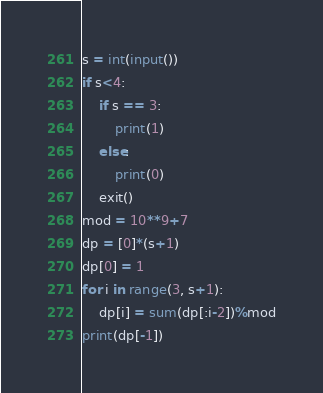Convert code to text. <code><loc_0><loc_0><loc_500><loc_500><_Python_>s = int(input())
if s<4:
    if s == 3:
        print(1)
    else:
        print(0)
    exit()
mod = 10**9+7
dp = [0]*(s+1)
dp[0] = 1
for i in range(3, s+1):
    dp[i] = sum(dp[:i-2])%mod
print(dp[-1])</code> 